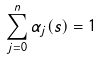<formula> <loc_0><loc_0><loc_500><loc_500>\sum _ { j = 0 } ^ { n } \alpha _ { j } ( s ) = 1</formula> 